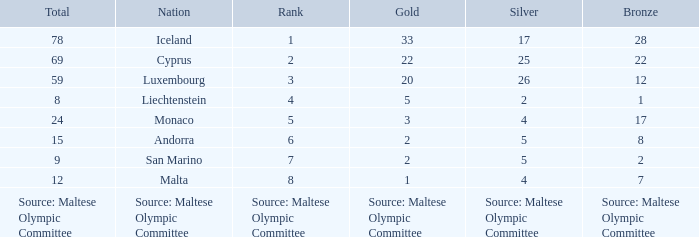How many bronze medals does the nation ranked number 1 have? 28.0. 